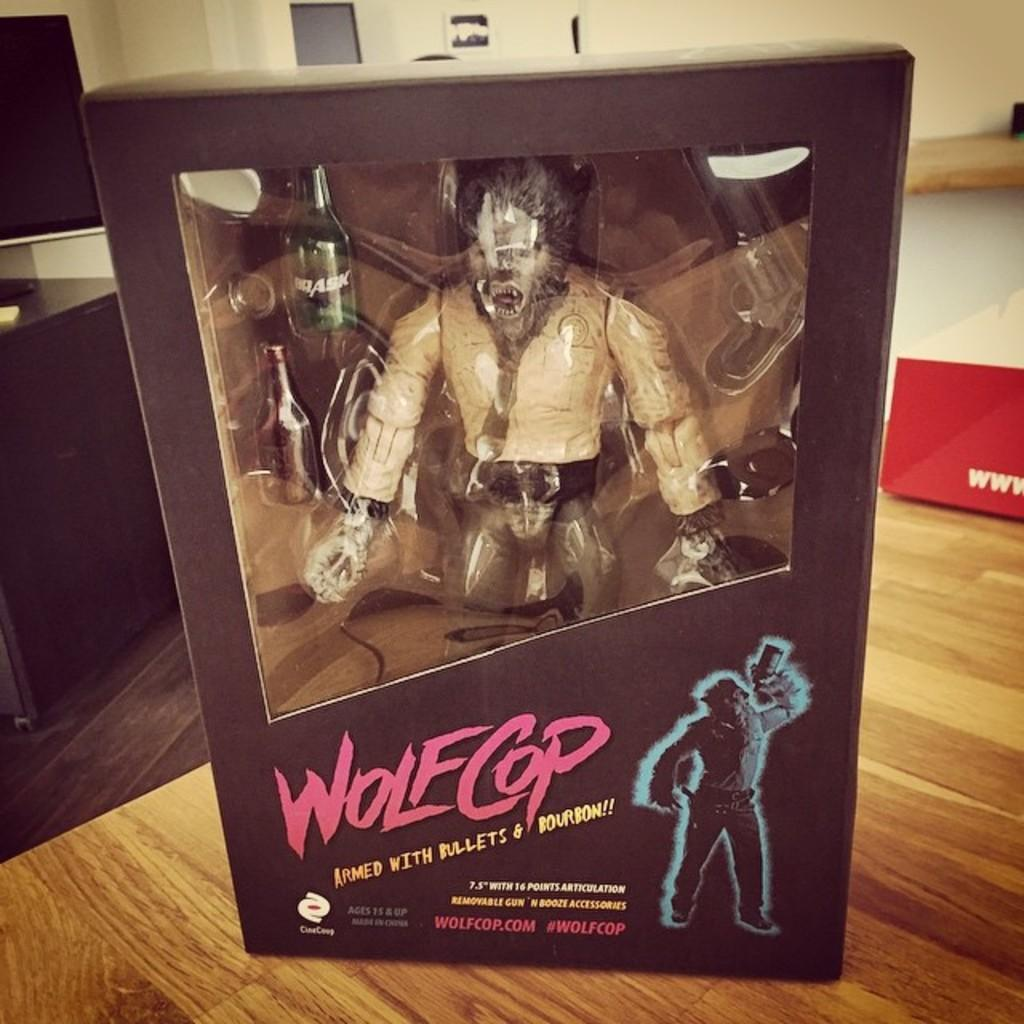<image>
Give a short and clear explanation of the subsequent image. a wolfcop figurine brand new in the box 